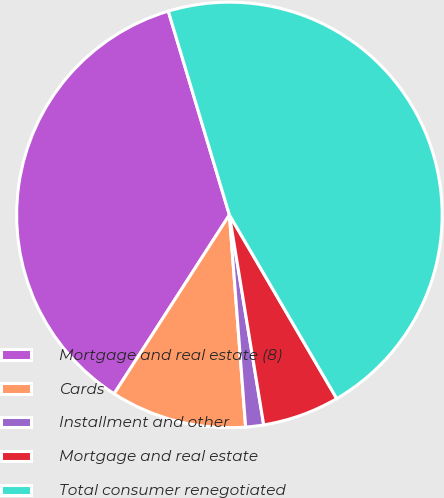<chart> <loc_0><loc_0><loc_500><loc_500><pie_chart><fcel>Mortgage and real estate (8)<fcel>Cards<fcel>Installment and other<fcel>Mortgage and real estate<fcel>Total consumer renegotiated<nl><fcel>36.25%<fcel>10.33%<fcel>1.36%<fcel>5.84%<fcel>46.22%<nl></chart> 